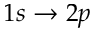<formula> <loc_0><loc_0><loc_500><loc_500>1 s \rightarrow 2 p</formula> 